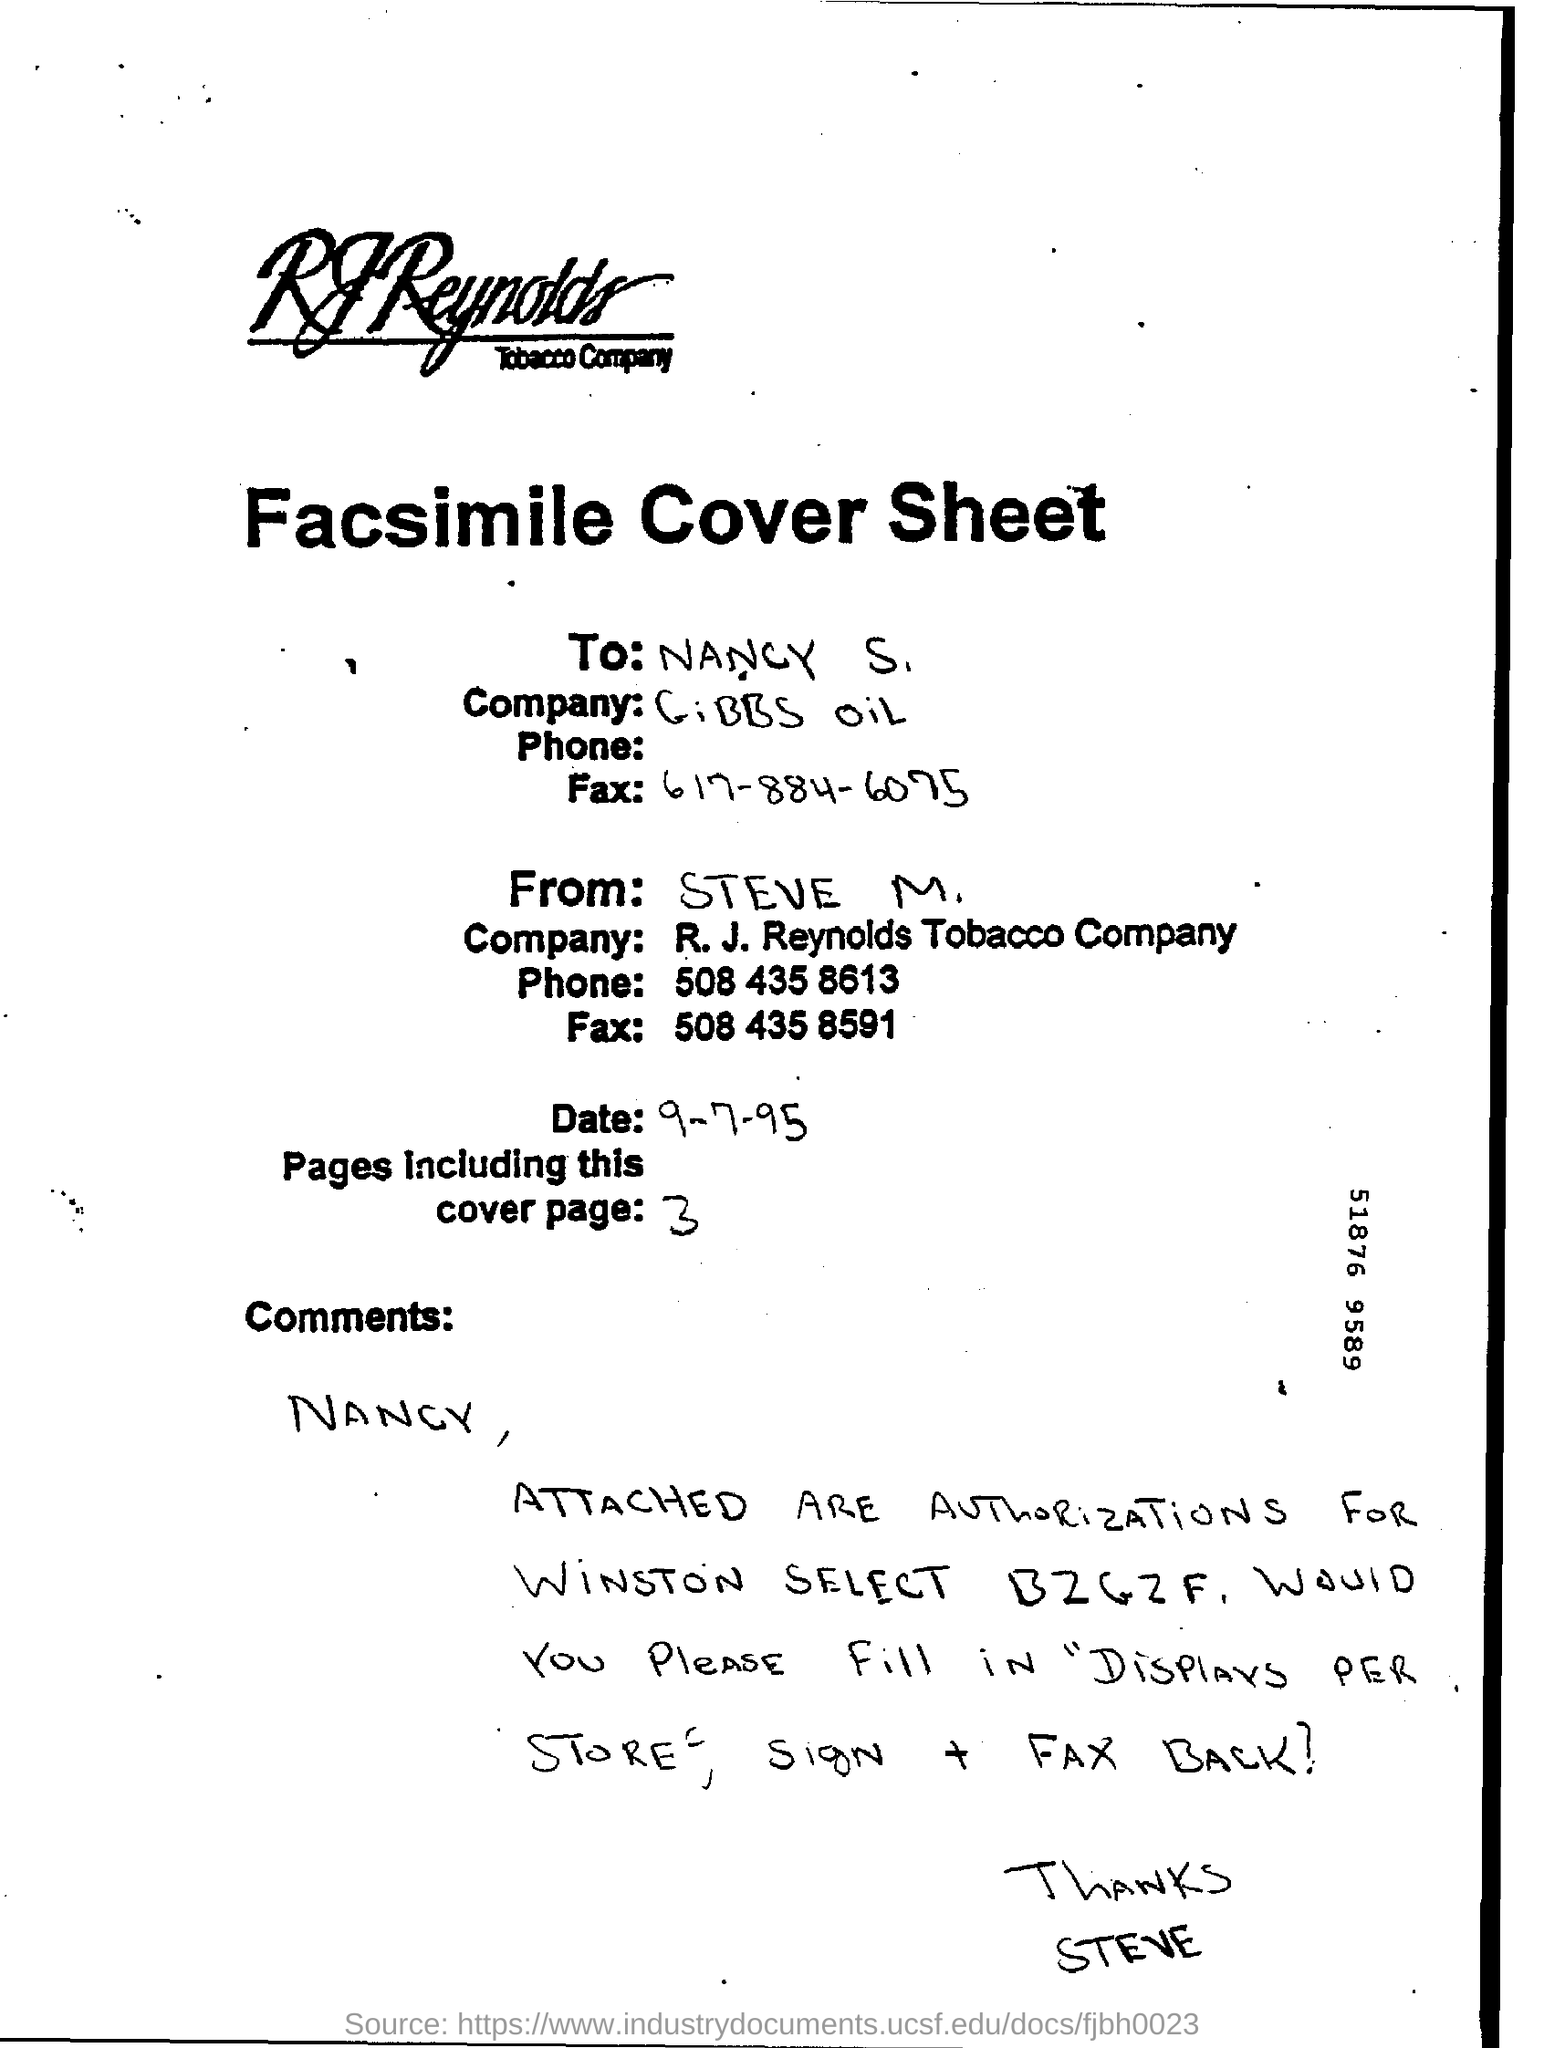Highlight a few significant elements in this photo. There are a total of 3 pages mentioned in the sheet. The Facsimile cover sheet is sent to Nancy S... The date of the sheet is unknown. Steve is the sender of the facsimile cover sheet. 